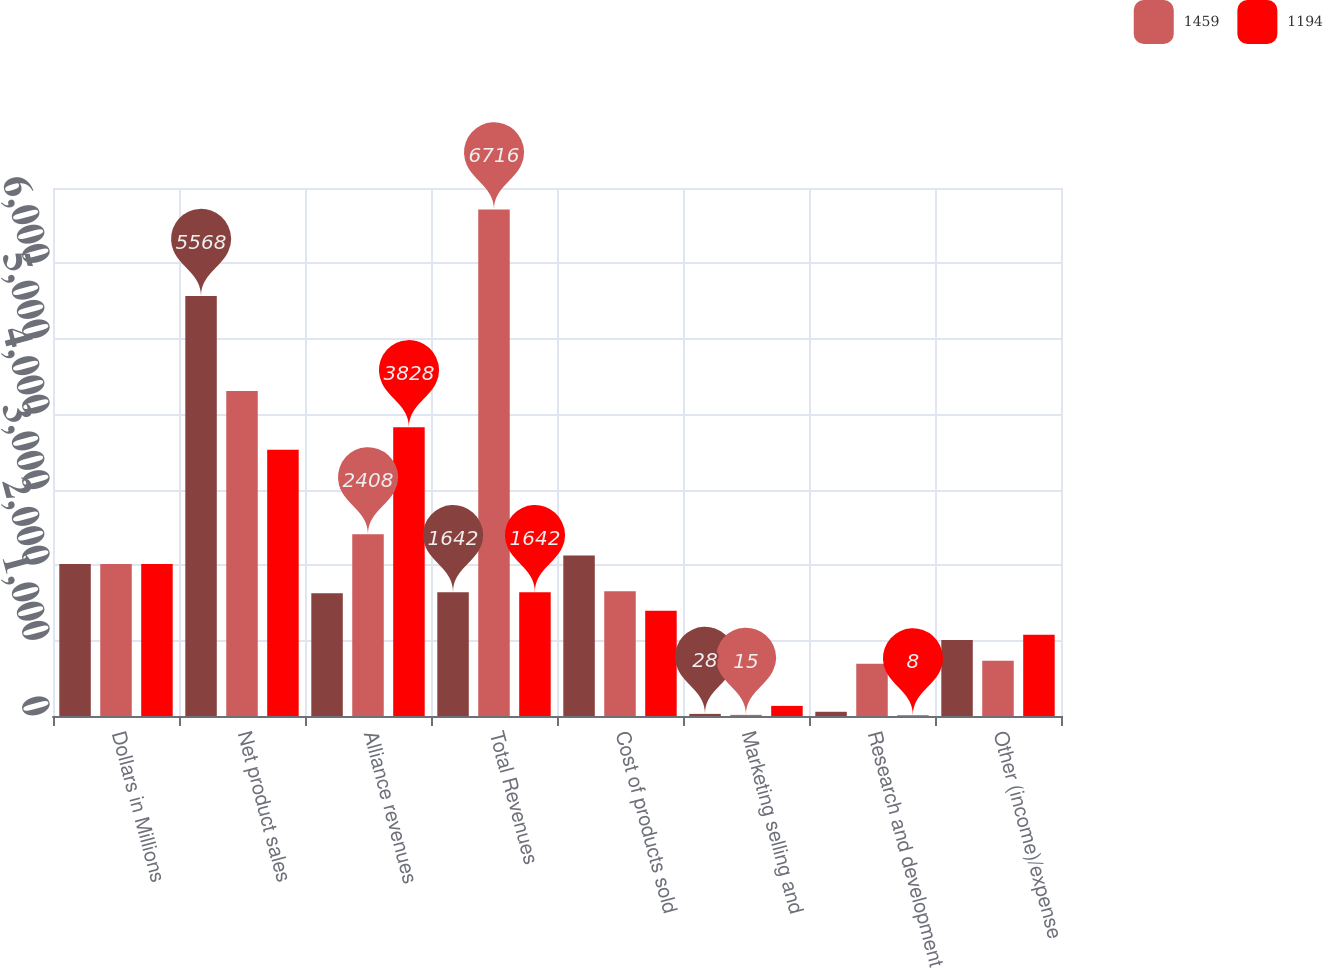Convert chart to OTSL. <chart><loc_0><loc_0><loc_500><loc_500><stacked_bar_chart><ecel><fcel>Dollars in Millions<fcel>Net product sales<fcel>Alliance revenues<fcel>Total Revenues<fcel>Cost of products sold<fcel>Marketing selling and<fcel>Research and development<fcel>Other (income)/expense<nl><fcel>nan<fcel>2016<fcel>5568<fcel>1629<fcel>1642<fcel>2129<fcel>28<fcel>56<fcel>1009<nl><fcel>1459<fcel>2015<fcel>4308<fcel>2408<fcel>6716<fcel>1655<fcel>15<fcel>693<fcel>733<nl><fcel>1194<fcel>2014<fcel>3531<fcel>3828<fcel>1642<fcel>1394<fcel>134<fcel>8<fcel>1076<nl></chart> 